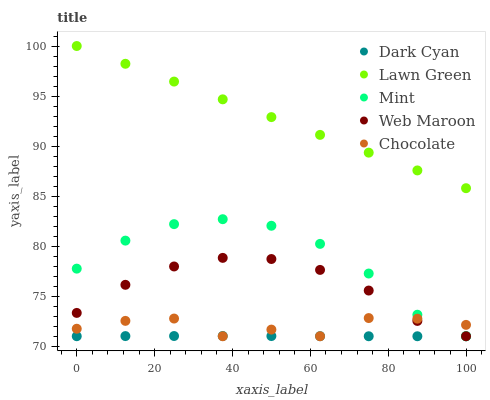Does Dark Cyan have the minimum area under the curve?
Answer yes or no. Yes. Does Lawn Green have the maximum area under the curve?
Answer yes or no. Yes. Does Mint have the minimum area under the curve?
Answer yes or no. No. Does Mint have the maximum area under the curve?
Answer yes or no. No. Is Lawn Green the smoothest?
Answer yes or no. Yes. Is Chocolate the roughest?
Answer yes or no. Yes. Is Mint the smoothest?
Answer yes or no. No. Is Mint the roughest?
Answer yes or no. No. Does Dark Cyan have the lowest value?
Answer yes or no. Yes. Does Lawn Green have the lowest value?
Answer yes or no. No. Does Lawn Green have the highest value?
Answer yes or no. Yes. Does Mint have the highest value?
Answer yes or no. No. Is Dark Cyan less than Lawn Green?
Answer yes or no. Yes. Is Lawn Green greater than Web Maroon?
Answer yes or no. Yes. Does Dark Cyan intersect Chocolate?
Answer yes or no. Yes. Is Dark Cyan less than Chocolate?
Answer yes or no. No. Is Dark Cyan greater than Chocolate?
Answer yes or no. No. Does Dark Cyan intersect Lawn Green?
Answer yes or no. No. 